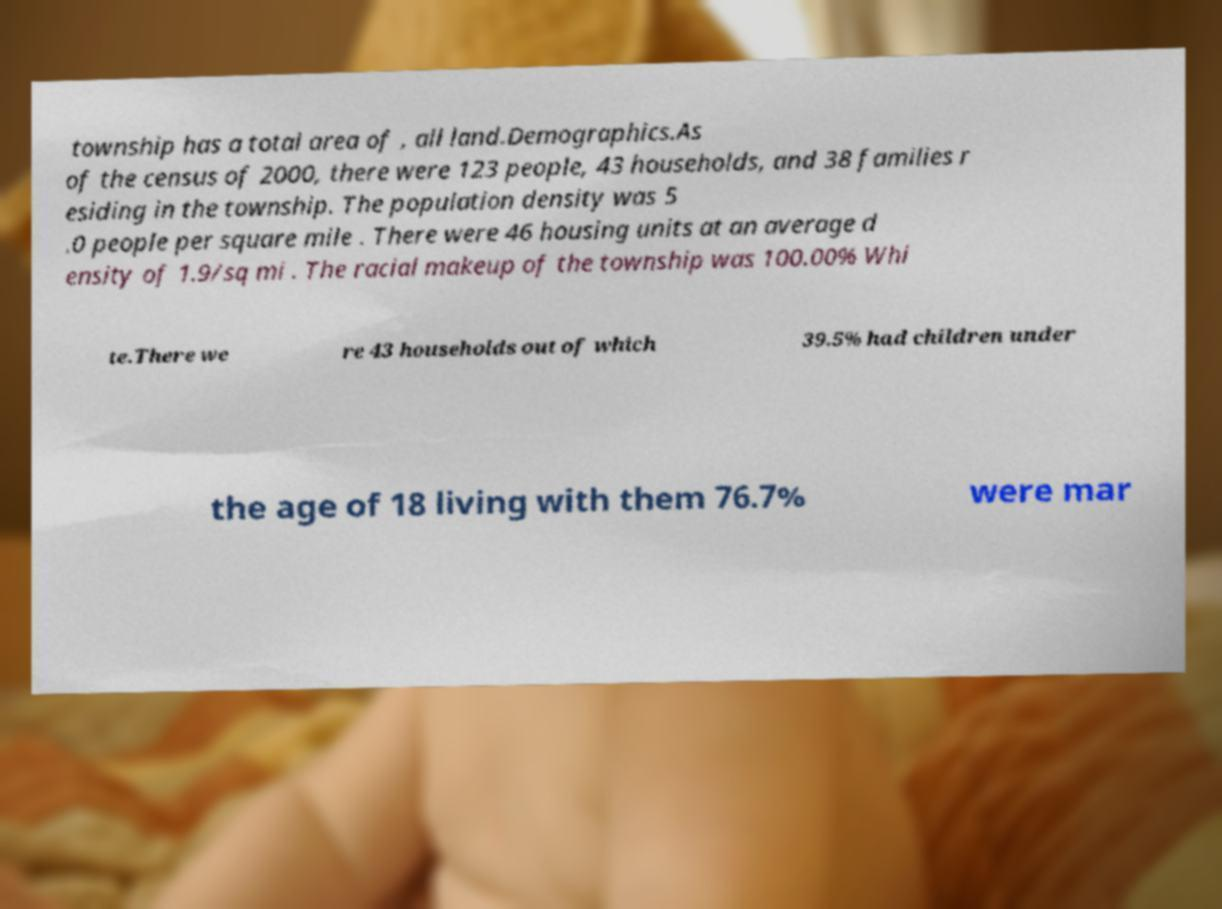Can you accurately transcribe the text from the provided image for me? township has a total area of , all land.Demographics.As of the census of 2000, there were 123 people, 43 households, and 38 families r esiding in the township. The population density was 5 .0 people per square mile . There were 46 housing units at an average d ensity of 1.9/sq mi . The racial makeup of the township was 100.00% Whi te.There we re 43 households out of which 39.5% had children under the age of 18 living with them 76.7% were mar 